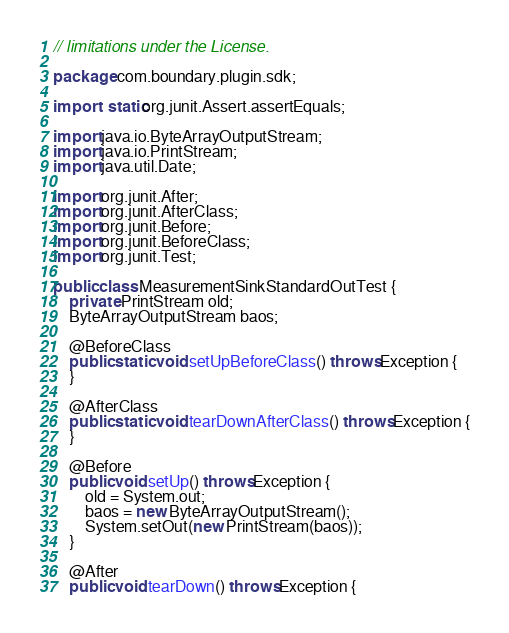<code> <loc_0><loc_0><loc_500><loc_500><_Java_>// limitations under the License.

package com.boundary.plugin.sdk;

import static org.junit.Assert.assertEquals;

import java.io.ByteArrayOutputStream;
import java.io.PrintStream;
import java.util.Date;

import org.junit.After;
import org.junit.AfterClass;
import org.junit.Before;
import org.junit.BeforeClass;
import org.junit.Test;

public class MeasurementSinkStandardOutTest {
	private PrintStream old;
	ByteArrayOutputStream baos;

	@BeforeClass
	public static void setUpBeforeClass() throws Exception {
	}

	@AfterClass
	public static void tearDownAfterClass() throws Exception {
	}

	@Before
	public void setUp() throws Exception {
		old = System.out;
		baos = new ByteArrayOutputStream();
		System.setOut(new PrintStream(baos));
	}

	@After
	public void tearDown() throws Exception {</code> 